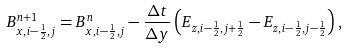<formula> <loc_0><loc_0><loc_500><loc_500>B _ { x , i - \frac { 1 } { 2 } , j } ^ { n + 1 } = B _ { x , i - \frac { 1 } { 2 } , j } ^ { n } - \frac { \Delta t } { \Delta y } \left ( E _ { z , i - \frac { 1 } { 2 } , j + \frac { 1 } { 2 } } - E _ { z , i - \frac { 1 } { 2 } , j - \frac { 1 } { 2 } } \right ) ,</formula> 